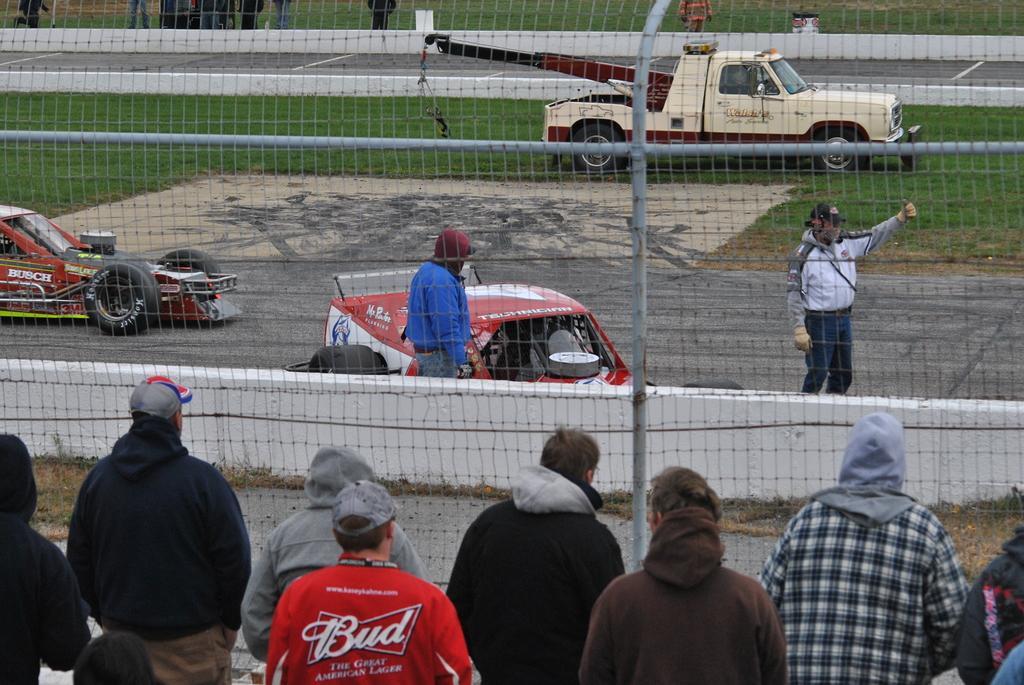Describe this image in one or two sentences. In this image, we can see people and are wearing coats and some are wearing caps. In the background there are vehicles and we can see a mesh and there is a wall and we can see ground. 